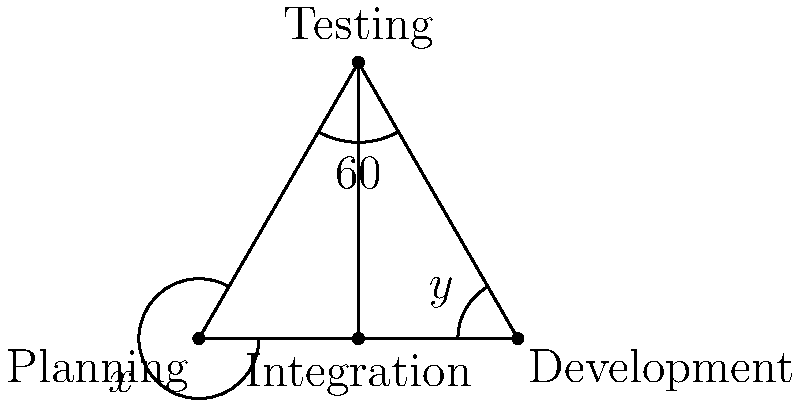In the software development lifecycle diagram above, the triangle represents the main stages: Planning, Development, and Testing. The Integration stage is represented by point D on the base of the triangle. If the angle at the Testing stage is 60°, and the angles formed by the Integration stage with Planning and Development are denoted as $x$ and $y$ respectively, what is the value of $x + y$? Let's approach this step-by-step:

1) In any triangle, the sum of all angles is 180°. Therefore, in triangle ABC:
   $\angle BAC + \angle ABC + \angle BCA = 180°$

2) We're given that $\angle BCA = 60°$. Let's call the other two angles:
   $\angle BAC = a$ and $\angle ABC = b$

3) From step 1 and 2:
   $a + b + 60° = 180°$
   $a + b = 120°$

4) The line CD creates two pairs of alternate angles with AB. Therefore:
   $x + a = 90°$ and $y + b = 90°$

5) Adding these equations:
   $(x + a) + (y + b) = 90° + 90° = 180°$

6) Expanding:
   $x + y + a + b = 180°$

7) But we know from step 3 that $a + b = 120°$. Substituting:
   $x + y + 120° = 180°$

8) Solving for $x + y$:
   $x + y = 180° - 120° = 60°$

Therefore, the sum of angles $x$ and $y$ is 60°.
Answer: 60° 